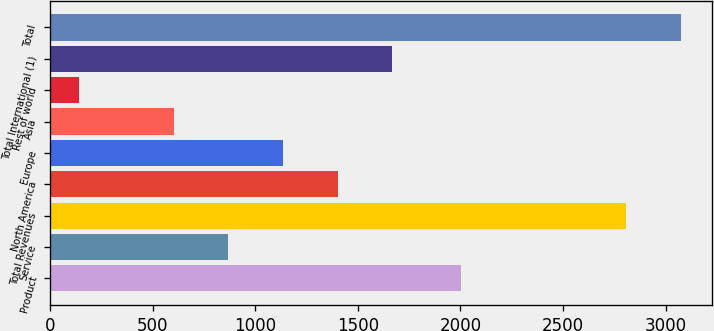Convert chart. <chart><loc_0><loc_0><loc_500><loc_500><bar_chart><fcel>Product<fcel>Service<fcel>Total Revenues<fcel>North America<fcel>Europe<fcel>Asia<fcel>Rest of world<fcel>Total International (1)<fcel>Total<nl><fcel>2004<fcel>868.7<fcel>2807<fcel>1402.1<fcel>1135.4<fcel>602<fcel>140<fcel>1668.8<fcel>3073.7<nl></chart> 